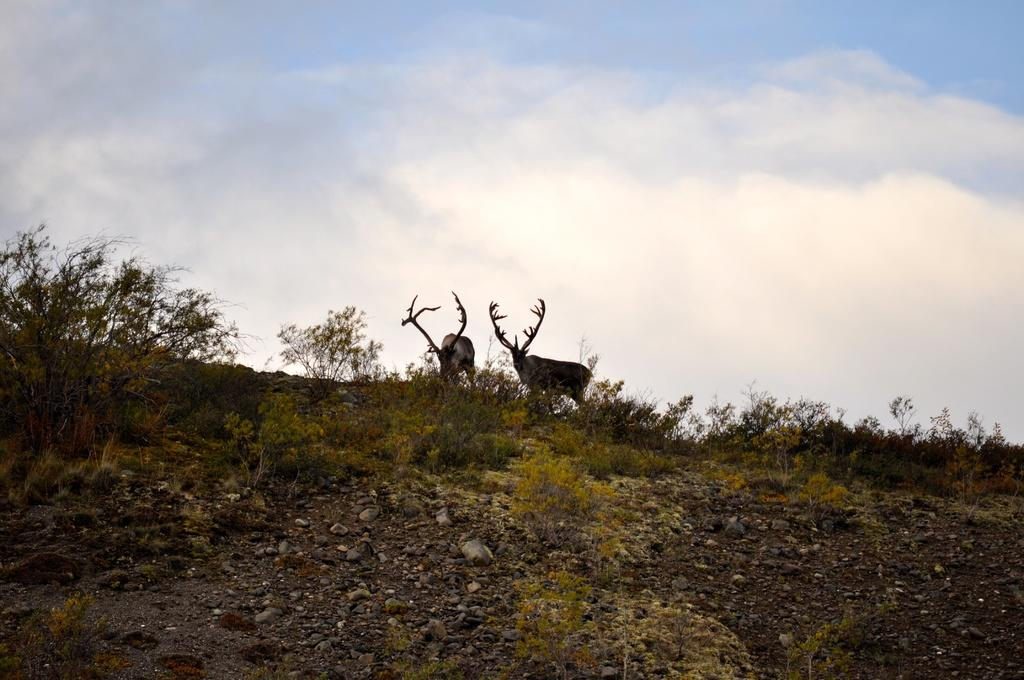What types of living organisms can be seen in the image? Plants and animals are visible in the image. What other objects can be seen in the image besides plants and animals? There are other objects in the image. What can be found at the bottom of the image? Stones, plants, and the ground are visible at the bottom of the image. What is visible at the top of the image? The sky is visible at the top of the image. What type of pancake can be seen in the image? There is no pancake present in the image. What color is the thread used to tie the animals together in the image? There is no thread or tied animals present in the image. 